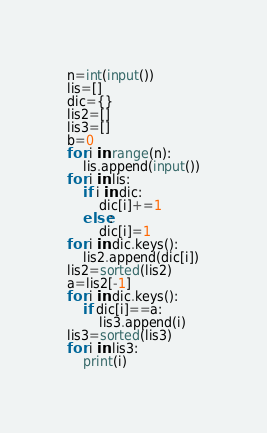<code> <loc_0><loc_0><loc_500><loc_500><_Python_>n=int(input())
lis=[]
dic={}
lis2=[]
lis3=[]
b=0
for i in range(n):
    lis.append(input())
for i in lis:
    if i in dic:
        dic[i]+=1
    else:
        dic[i]=1
for i in dic.keys():
    lis2.append(dic[i])
lis2=sorted(lis2)
a=lis2[-1]
for i in dic.keys():
    if dic[i]==a:
        lis3.append(i)
lis3=sorted(lis3)
for i in lis3:
    print(i)</code> 